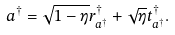<formula> <loc_0><loc_0><loc_500><loc_500>a ^ { \dagger } = \sqrt { 1 - \eta } r _ { a ^ { \dagger } } ^ { \dagger } + \sqrt { \eta } t _ { a ^ { \dagger } } ^ { \dagger } .</formula> 